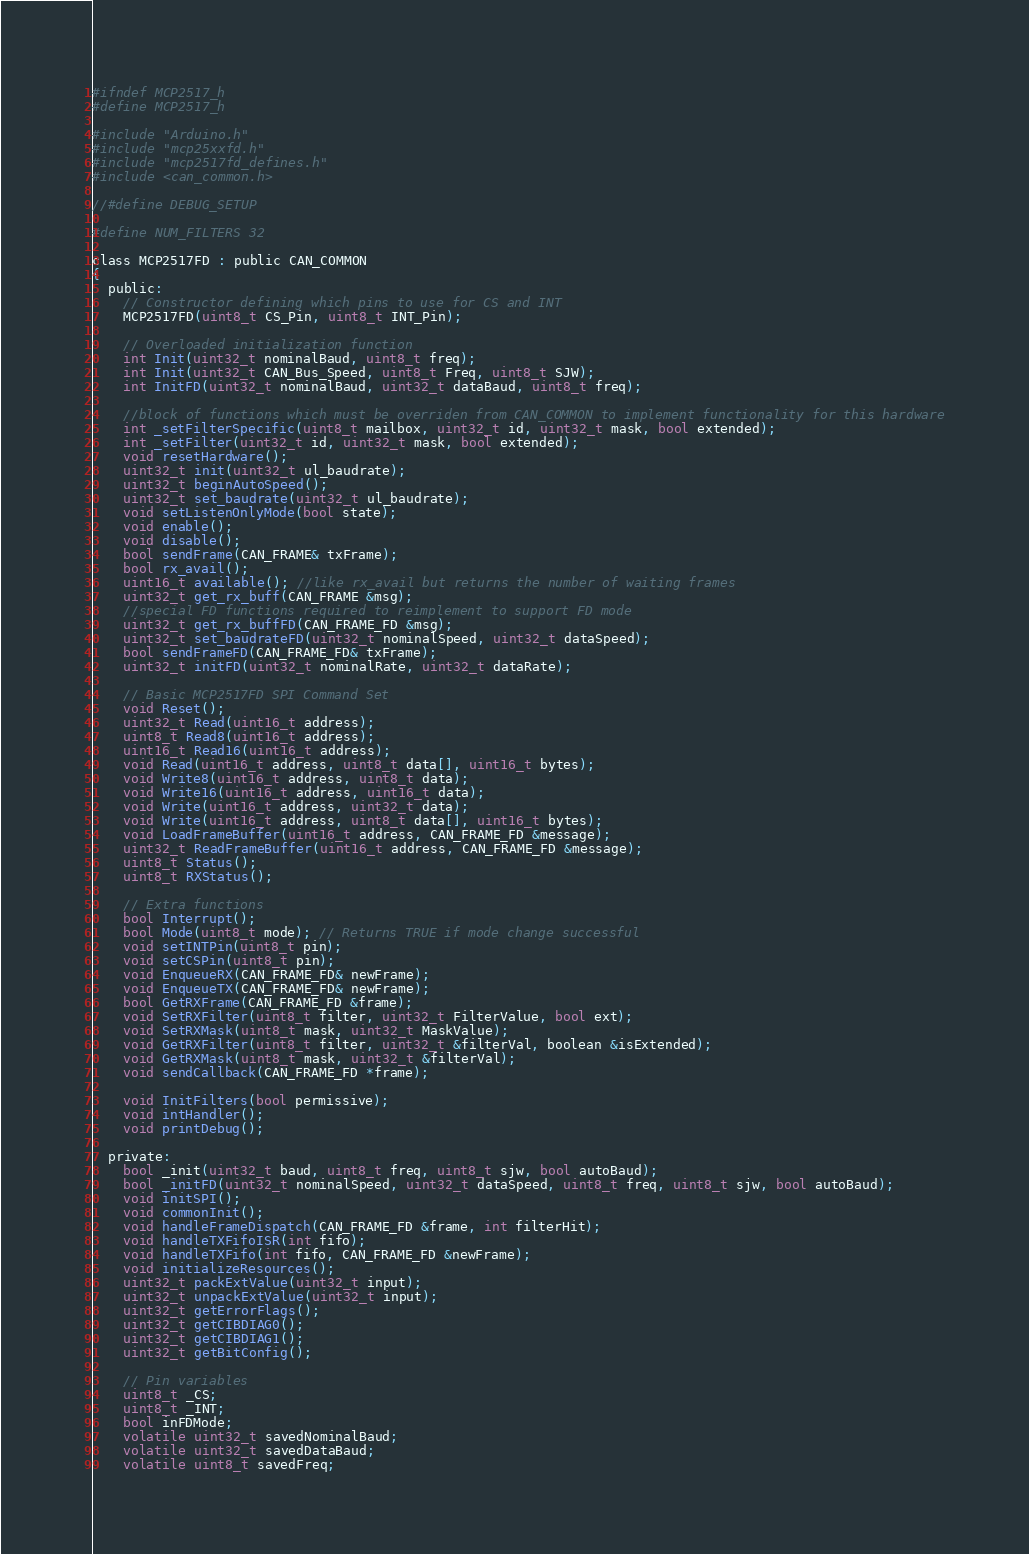<code> <loc_0><loc_0><loc_500><loc_500><_C_>#ifndef MCP2517_h
#define MCP2517_h

#include "Arduino.h"
#include "mcp25xxfd.h"
#include "mcp2517fd_defines.h"
#include <can_common.h>

//#define DEBUG_SETUP

#define NUM_FILTERS 32

class MCP2517FD : public CAN_COMMON
{
  public:
	// Constructor defining which pins to use for CS and INT
    MCP2517FD(uint8_t CS_Pin, uint8_t INT_Pin);
	
	// Overloaded initialization function
	int Init(uint32_t nominalBaud, uint8_t freq);
	int Init(uint32_t CAN_Bus_Speed, uint8_t Freq, uint8_t SJW);
	int InitFD(uint32_t nominalBaud, uint32_t dataBaud, uint8_t freq);

    //block of functions which must be overriden from CAN_COMMON to implement functionality for this hardware
	int _setFilterSpecific(uint8_t mailbox, uint32_t id, uint32_t mask, bool extended);
    int _setFilter(uint32_t id, uint32_t mask, bool extended);
	void resetHardware();
	uint32_t init(uint32_t ul_baudrate);
    uint32_t beginAutoSpeed();
    uint32_t set_baudrate(uint32_t ul_baudrate);
    void setListenOnlyMode(bool state);
	void enable();
	void disable();
	bool sendFrame(CAN_FRAME& txFrame);
	bool rx_avail();
	uint16_t available(); //like rx_avail but returns the number of waiting frames
	uint32_t get_rx_buff(CAN_FRAME &msg);
	//special FD functions required to reimplement to support FD mode
	uint32_t get_rx_buffFD(CAN_FRAME_FD &msg);
    uint32_t set_baudrateFD(uint32_t nominalSpeed, uint32_t dataSpeed);
    bool sendFrameFD(CAN_FRAME_FD& txFrame);
    uint32_t initFD(uint32_t nominalRate, uint32_t dataRate);
	
	// Basic MCP2517FD SPI Command Set
    void Reset();
    uint32_t Read(uint16_t address);
	uint8_t Read8(uint16_t address);
	uint16_t Read16(uint16_t address);
    void Read(uint16_t address, uint8_t data[], uint16_t bytes);
	void Write8(uint16_t address, uint8_t data);
	void Write16(uint16_t address, uint16_t data);
	void Write(uint16_t address, uint32_t data);
	void Write(uint16_t address, uint8_t data[], uint16_t bytes);
	void LoadFrameBuffer(uint16_t address, CAN_FRAME_FD &message);
	uint32_t ReadFrameBuffer(uint16_t address, CAN_FRAME_FD &message);
	uint8_t Status();
	uint8_t RXStatus();

	// Extra functions
	bool Interrupt();
	bool Mode(uint8_t mode); // Returns TRUE if mode change successful
	void setINTPin(uint8_t pin);
	void setCSPin(uint8_t pin);
	void EnqueueRX(CAN_FRAME_FD& newFrame);
	void EnqueueTX(CAN_FRAME_FD& newFrame);
	bool GetRXFrame(CAN_FRAME_FD &frame);
	void SetRXFilter(uint8_t filter, uint32_t FilterValue, bool ext);
	void SetRXMask(uint8_t mask, uint32_t MaskValue);
    void GetRXFilter(uint8_t filter, uint32_t &filterVal, boolean &isExtended);
    void GetRXMask(uint8_t mask, uint32_t &filterVal);
	void sendCallback(CAN_FRAME_FD *frame);

	void InitFilters(bool permissive);
	void intHandler();
	void printDebug();

  private:
	bool _init(uint32_t baud, uint8_t freq, uint8_t sjw, bool autoBaud);
	bool _initFD(uint32_t nominalSpeed, uint32_t dataSpeed, uint8_t freq, uint8_t sjw, bool autoBaud);
	void initSPI();
	void commonInit();
    void handleFrameDispatch(CAN_FRAME_FD &frame, int filterHit);
	void handleTXFifoISR(int fifo);
	void handleTXFifo(int fifo, CAN_FRAME_FD &newFrame);
    void initializeResources();
	uint32_t packExtValue(uint32_t input);
	uint32_t unpackExtValue(uint32_t input);
	uint32_t getErrorFlags();
	uint32_t getCIBDIAG0();
	uint32_t getCIBDIAG1();
	uint32_t getBitConfig();

    // Pin variables
	uint8_t _CS;
	uint8_t _INT;
	bool inFDMode;
	volatile uint32_t savedNominalBaud;
	volatile uint32_t savedDataBaud;
	volatile uint8_t savedFreq;</code> 